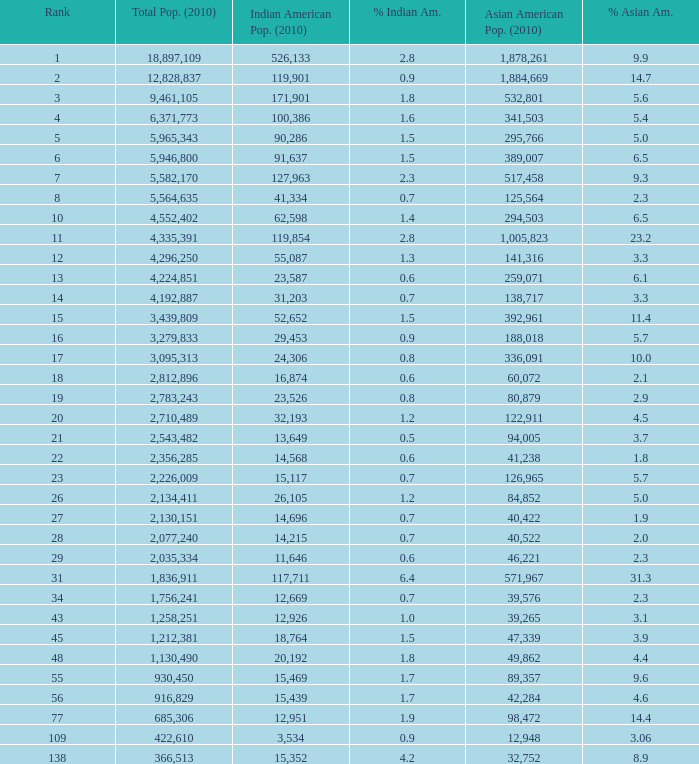What's the total population when the Asian American population is less than 60,072, the Indian American population is more than 14,696 and is 4.2% Indian American? 366513.0. 